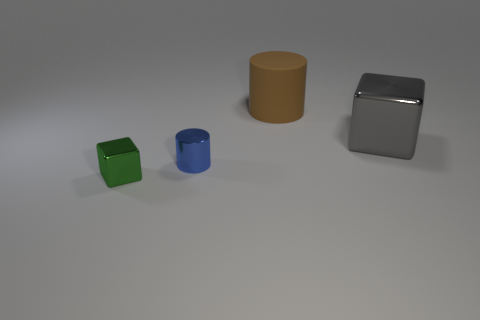Add 1 rubber objects. How many objects exist? 5 Subtract all small blocks. Subtract all tiny yellow matte cubes. How many objects are left? 3 Add 1 small green things. How many small green things are left? 2 Add 1 big cylinders. How many big cylinders exist? 2 Subtract 0 cyan spheres. How many objects are left? 4 